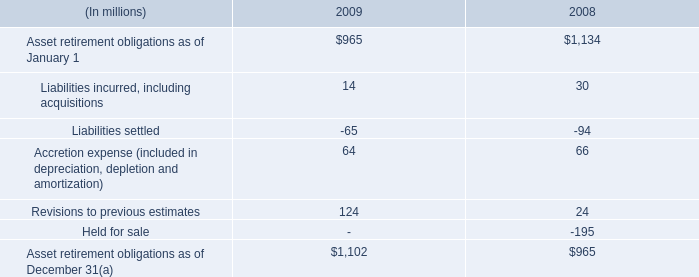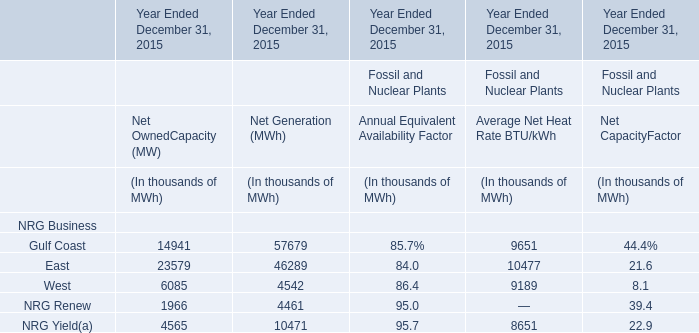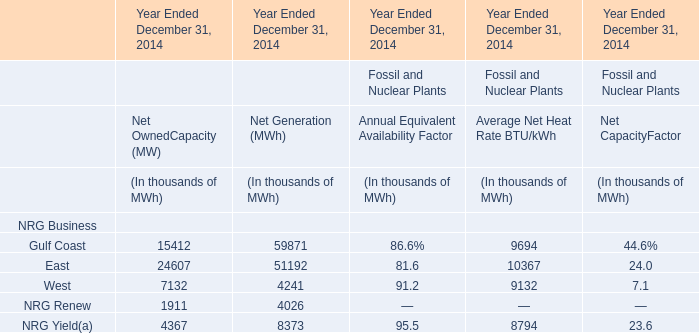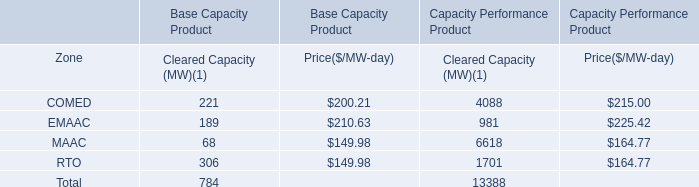What is the percentage of all Average Net Heat Rate BTU/kWh that are positive to the total amount, in 2014 
Computations: ((((9694 + 10367) + 9132) + 8794) / (((9694 + 10367) + 9132) + 8794))
Answer: 1.0. 